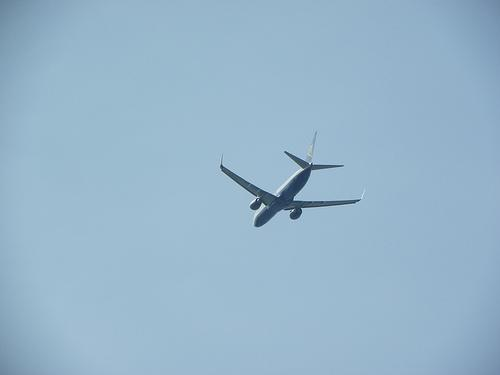In the multi-choice VQA task, choose the most accurate description of the sky in the image. The sky is blue in color and clear. For the visual entailment task, determine if the airplane is big or small. The airplane is big in size. Design a product advertisement for this airplane by highlighting its key features. Introducing the sleek and modern aircraft, designed with streamlined head and sharp, long wings for ultimate performance, and powered by two powerful engines. Experience the finest in aviation with this piece of metallic engineering marvel, soaring high in the clear, blue sky. List three features of the sky in the image. The sky is blue, clear, and expansive. Can you describe the appearance of the airplane and its parts? The airplane is white in color, has a streamlined body, long wings on both sides, two engines, and a metallic body. What do you conclude about the airplane's material and construction from the given information? The airplane is made of metal and has a metallic construction, contributing to its strength and aerodynamic performance. What is the prominent color in the image and where is it found? The prominent color in the image is blue, which can be found in the sky. 